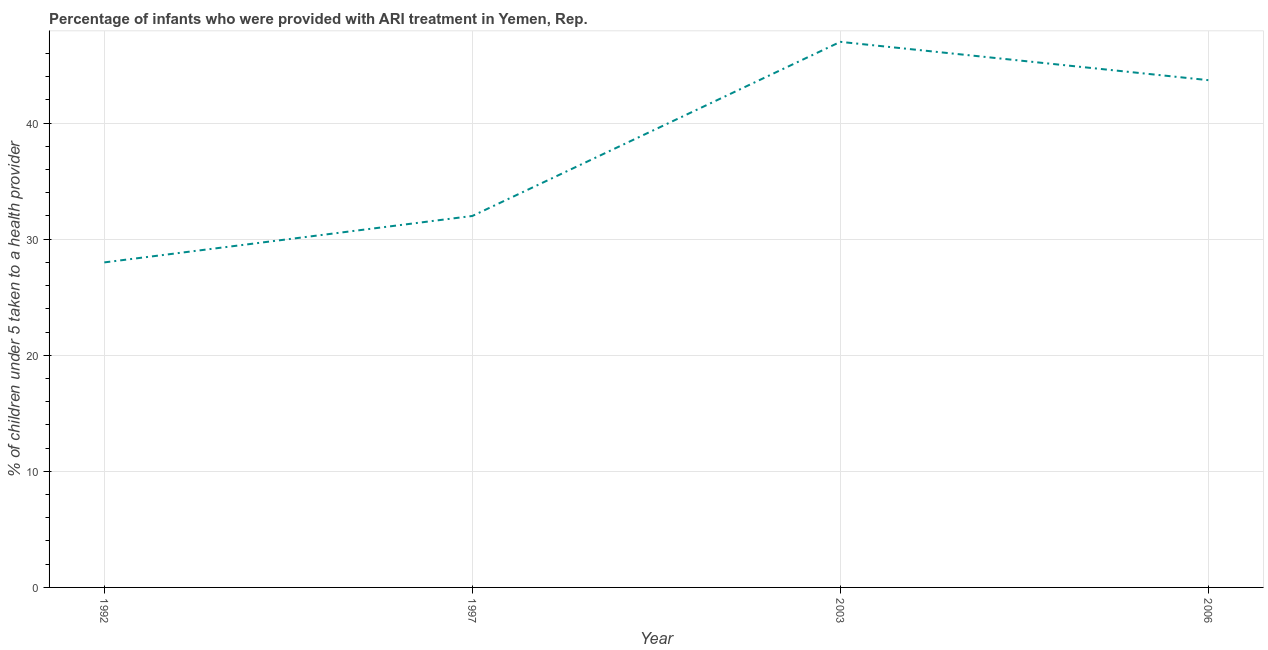Across all years, what is the minimum percentage of children who were provided with ari treatment?
Keep it short and to the point. 28. In which year was the percentage of children who were provided with ari treatment minimum?
Offer a terse response. 1992. What is the sum of the percentage of children who were provided with ari treatment?
Provide a succinct answer. 150.7. What is the difference between the percentage of children who were provided with ari treatment in 1997 and 2003?
Provide a short and direct response. -15. What is the average percentage of children who were provided with ari treatment per year?
Provide a short and direct response. 37.67. What is the median percentage of children who were provided with ari treatment?
Your answer should be compact. 37.85. In how many years, is the percentage of children who were provided with ari treatment greater than 30 %?
Offer a very short reply. 3. What is the ratio of the percentage of children who were provided with ari treatment in 2003 to that in 2006?
Your answer should be compact. 1.08. Is the difference between the percentage of children who were provided with ari treatment in 1992 and 2006 greater than the difference between any two years?
Your answer should be very brief. No. What is the difference between the highest and the second highest percentage of children who were provided with ari treatment?
Keep it short and to the point. 3.3. What is the difference between the highest and the lowest percentage of children who were provided with ari treatment?
Provide a succinct answer. 19. Does the percentage of children who were provided with ari treatment monotonically increase over the years?
Your answer should be very brief. No. What is the difference between two consecutive major ticks on the Y-axis?
Give a very brief answer. 10. Are the values on the major ticks of Y-axis written in scientific E-notation?
Your answer should be compact. No. Does the graph contain any zero values?
Give a very brief answer. No. What is the title of the graph?
Ensure brevity in your answer.  Percentage of infants who were provided with ARI treatment in Yemen, Rep. What is the label or title of the Y-axis?
Provide a short and direct response. % of children under 5 taken to a health provider. What is the % of children under 5 taken to a health provider in 1992?
Ensure brevity in your answer.  28. What is the % of children under 5 taken to a health provider in 2003?
Provide a short and direct response. 47. What is the % of children under 5 taken to a health provider of 2006?
Your response must be concise. 43.7. What is the difference between the % of children under 5 taken to a health provider in 1992 and 1997?
Keep it short and to the point. -4. What is the difference between the % of children under 5 taken to a health provider in 1992 and 2003?
Provide a succinct answer. -19. What is the difference between the % of children under 5 taken to a health provider in 1992 and 2006?
Your answer should be compact. -15.7. What is the difference between the % of children under 5 taken to a health provider in 1997 and 2006?
Make the answer very short. -11.7. What is the difference between the % of children under 5 taken to a health provider in 2003 and 2006?
Provide a short and direct response. 3.3. What is the ratio of the % of children under 5 taken to a health provider in 1992 to that in 1997?
Keep it short and to the point. 0.88. What is the ratio of the % of children under 5 taken to a health provider in 1992 to that in 2003?
Your response must be concise. 0.6. What is the ratio of the % of children under 5 taken to a health provider in 1992 to that in 2006?
Your answer should be very brief. 0.64. What is the ratio of the % of children under 5 taken to a health provider in 1997 to that in 2003?
Ensure brevity in your answer.  0.68. What is the ratio of the % of children under 5 taken to a health provider in 1997 to that in 2006?
Provide a short and direct response. 0.73. What is the ratio of the % of children under 5 taken to a health provider in 2003 to that in 2006?
Provide a short and direct response. 1.08. 